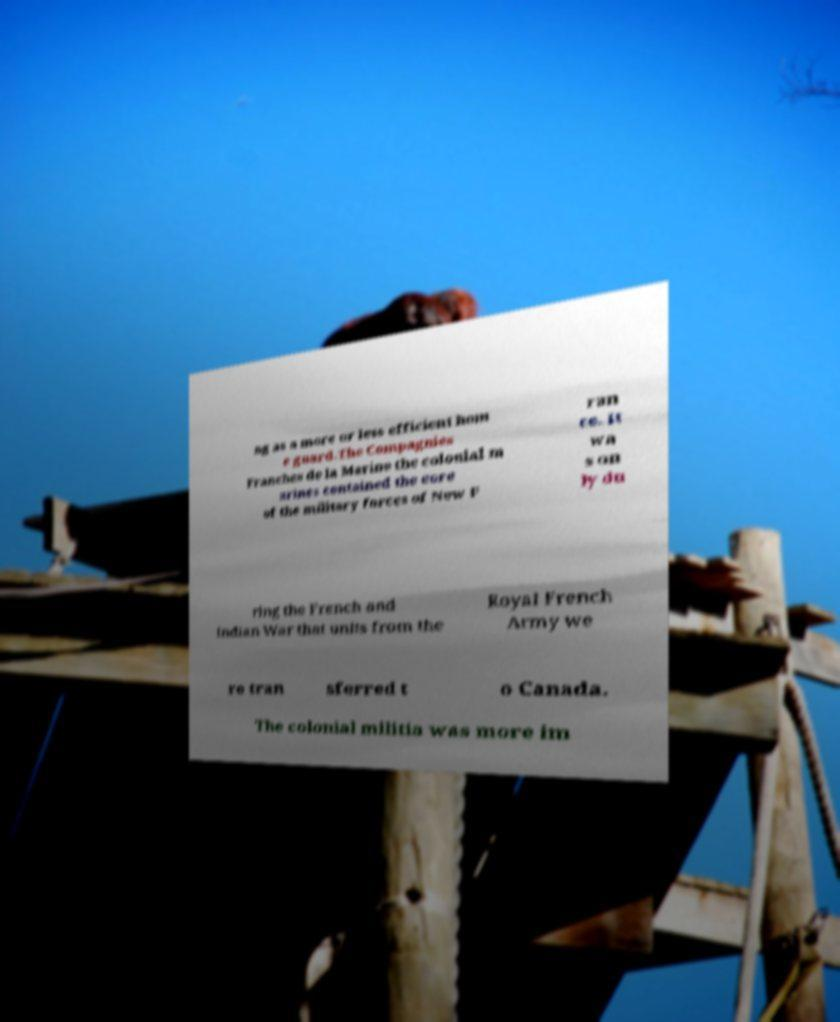Can you read and provide the text displayed in the image?This photo seems to have some interesting text. Can you extract and type it out for me? ng as a more or less efficient hom e guard.The Compagnies Franches de la Marine the colonial m arines contained the core of the military forces of New F ran ce. It wa s on ly du ring the French and Indian War that units from the Royal French Army we re tran sferred t o Canada. The colonial militia was more im 